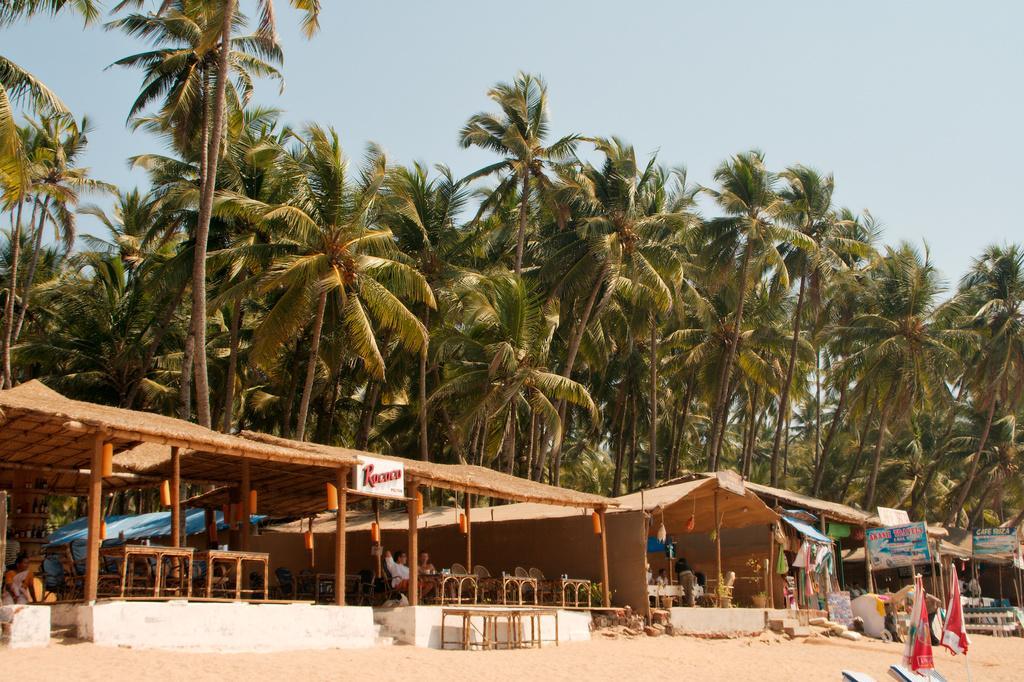Please provide a concise description of this image. We can see umbrellas, chairs and sand. We can see tables, sheds, chairs, boards and few objects. There are people. In the background we can see trees and sky. 